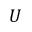Convert formula to latex. <formula><loc_0><loc_0><loc_500><loc_500>U</formula> 